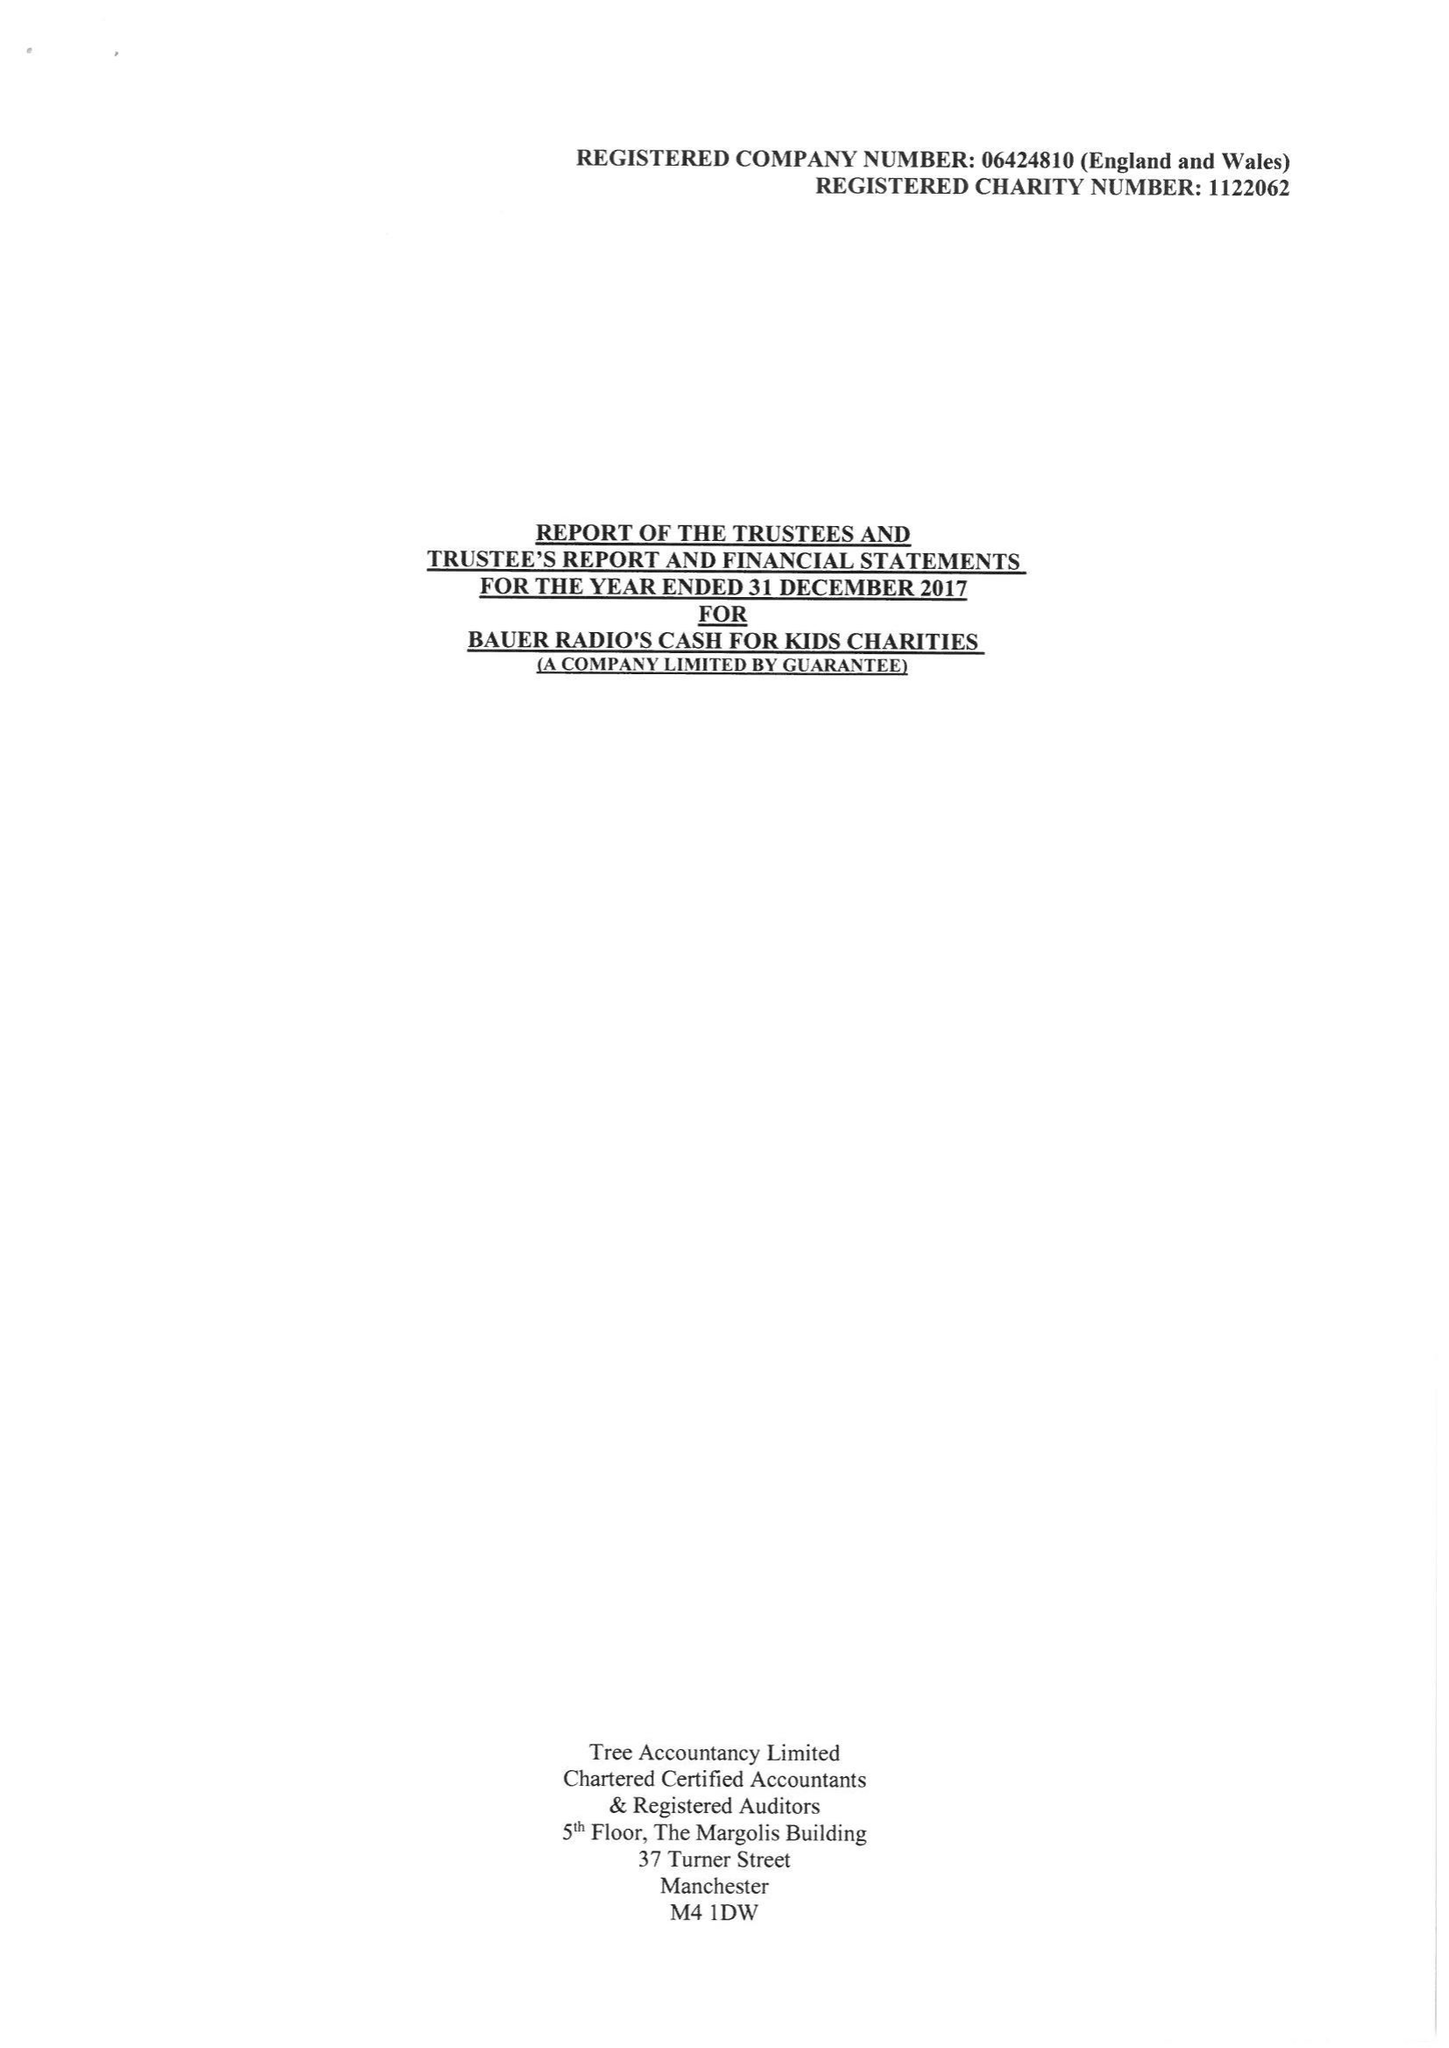What is the value for the income_annually_in_british_pounds?
Answer the question using a single word or phrase. 17259816.00 